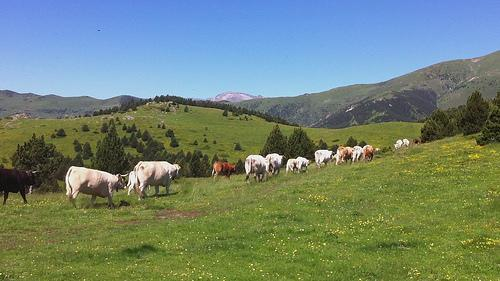Question: where is this picture taken?
Choices:
A. A river.
B. A mountain top.
C. A field.
D. In school.
Answer with the letter. Answer: C Question: what animals are shown?
Choices:
A. Horses.
B. Chickens.
C. Donkeys.
D. Cows.
Answer with the letter. Answer: D Question: what color is the grass?
Choices:
A. Yellow.
B. Brown.
C. Orange.
D. Green.
Answer with the letter. Answer: D Question: how is the weather?
Choices:
A. Rainy.
B. Sunny.
C. Cloudy.
D. Misty.
Answer with the letter. Answer: B Question: what are the cows doing?
Choices:
A. Walking.
B. Grazing.
C. Drinking.
D. Sleeping.
Answer with the letter. Answer: A 